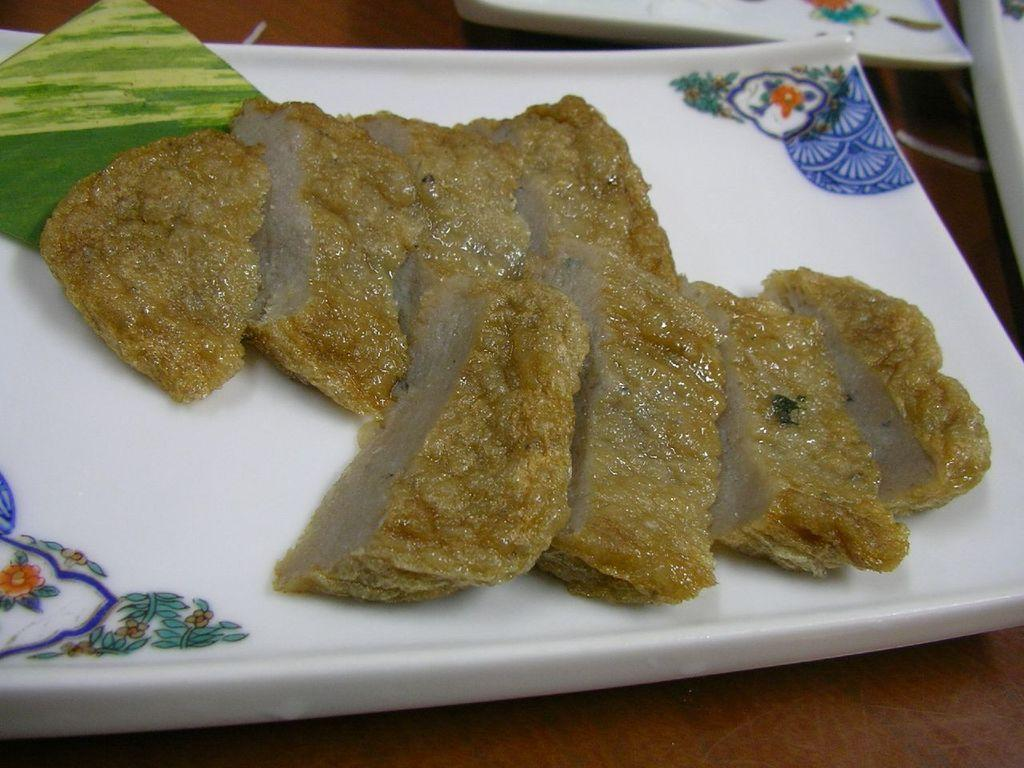What is on the plate that is visible in the image? There is a plate with food in the image. What can be said about the color of the food on the plate? The food is brown in color. What is the color of the plate? The plate is white in color. Are there any other plates visible in the image? Yes, there are additional plates visible in the image. Where are the plates located in the image? The plates are on a table. How many lizards can be seen laughing on the plates in the image? There are no lizards present in the image, and they cannot laugh as they are not capable of such behavior. 